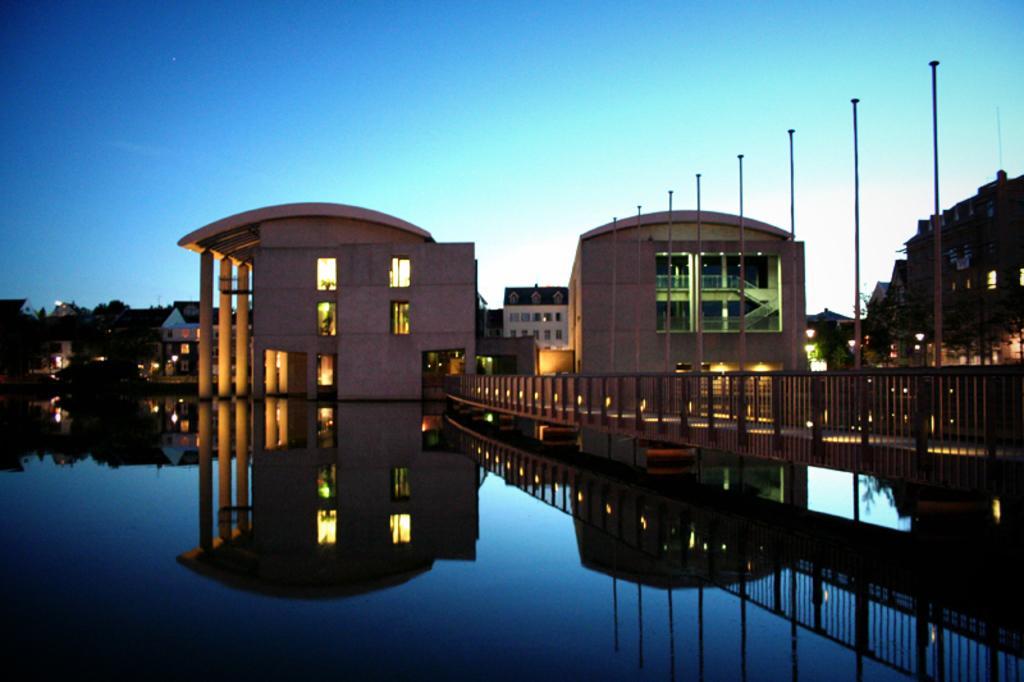Describe this image in one or two sentences. On the left side, there is water. On the right side, there is a bridge having a fence on both sides. In the background, there are trees, buildings and there are clouds in the blue sky. 